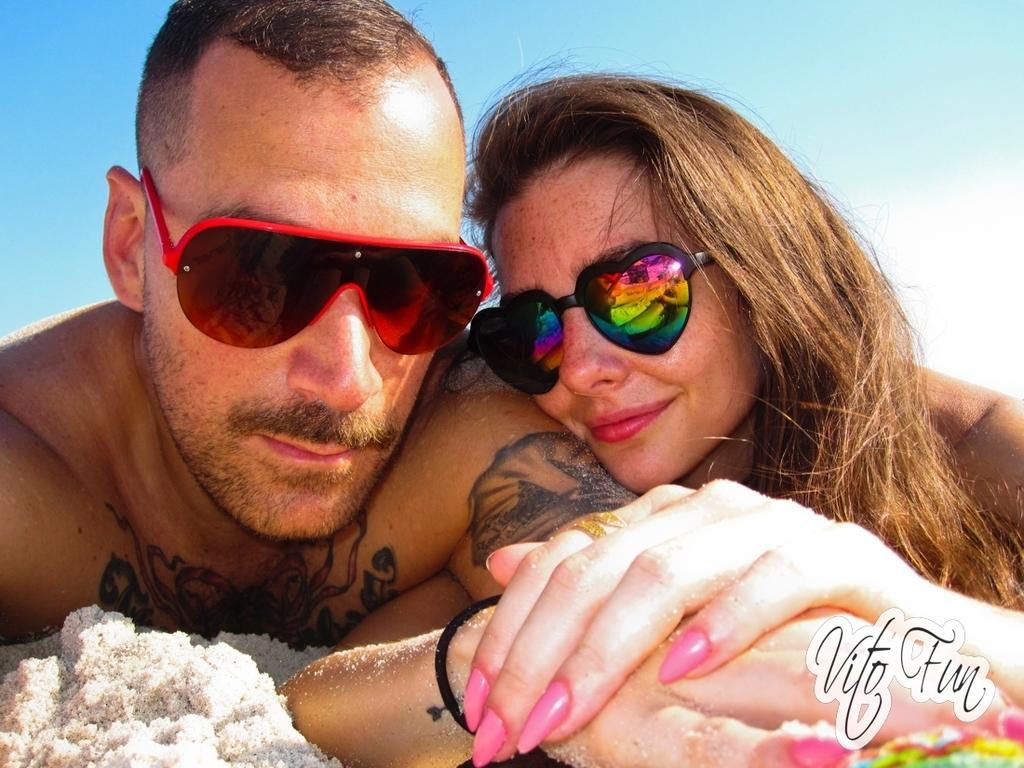How many people are present in the image? There are two people in the image, a man and a woman. What expressions do the man and woman have in the image? Both the man and woman are smiling in the image. What type of protective eyewear are the man and woman wearing? The man and woman are wearing goggles in the image. What type of environment can be seen in the image? The image appears to be set in a sandy environment. What part of the natural environment is visible in the image? The sky is visible in the image. How many spiders can be seen crawling on the man's face in the image? There are no spiders visible on the man's face in the image. Is there a boy present in the image? The image only features a man and a woman; there is no boy present. 